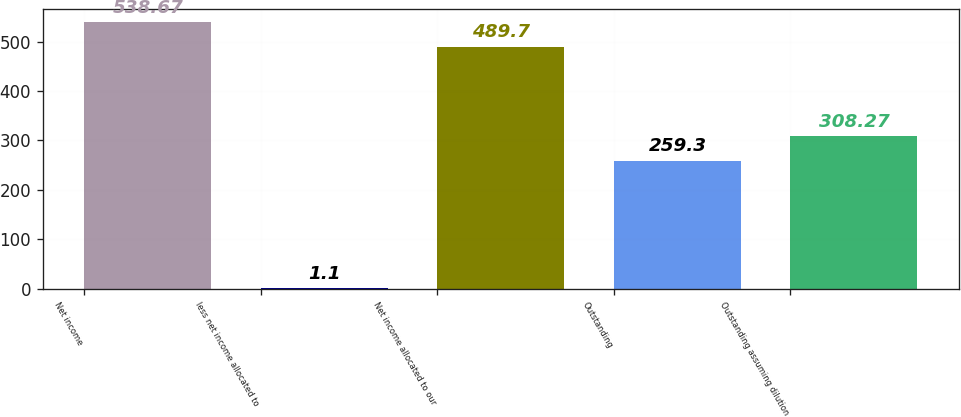Convert chart. <chart><loc_0><loc_0><loc_500><loc_500><bar_chart><fcel>Net income<fcel>less net income allocated to<fcel>Net income allocated to our<fcel>Outstanding<fcel>Outstanding assuming dilution<nl><fcel>538.67<fcel>1.1<fcel>489.7<fcel>259.3<fcel>308.27<nl></chart> 